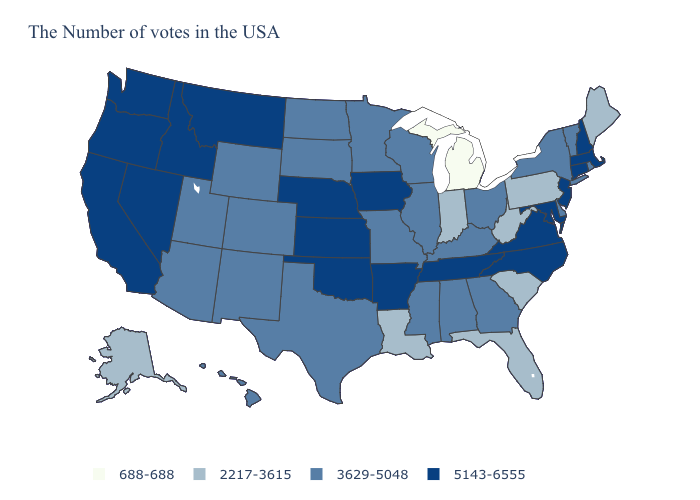Does Massachusetts have the lowest value in the Northeast?
Write a very short answer. No. What is the lowest value in the MidWest?
Concise answer only. 688-688. Does Nebraska have the highest value in the USA?
Quick response, please. Yes. Name the states that have a value in the range 5143-6555?
Answer briefly. Massachusetts, New Hampshire, Connecticut, New Jersey, Maryland, Virginia, North Carolina, Tennessee, Arkansas, Iowa, Kansas, Nebraska, Oklahoma, Montana, Idaho, Nevada, California, Washington, Oregon. What is the lowest value in states that border New Mexico?
Concise answer only. 3629-5048. What is the value of Connecticut?
Answer briefly. 5143-6555. Does Delaware have a lower value than New Mexico?
Short answer required. No. Does Michigan have the lowest value in the USA?
Keep it brief. Yes. What is the lowest value in states that border Washington?
Short answer required. 5143-6555. What is the highest value in the USA?
Be succinct. 5143-6555. Among the states that border Texas , which have the lowest value?
Quick response, please. Louisiana. What is the lowest value in states that border Virginia?
Concise answer only. 2217-3615. Does Oklahoma have the same value as Nebraska?
Keep it brief. Yes. Which states have the lowest value in the West?
Be succinct. Alaska. Which states have the lowest value in the Northeast?
Concise answer only. Maine, Pennsylvania. 